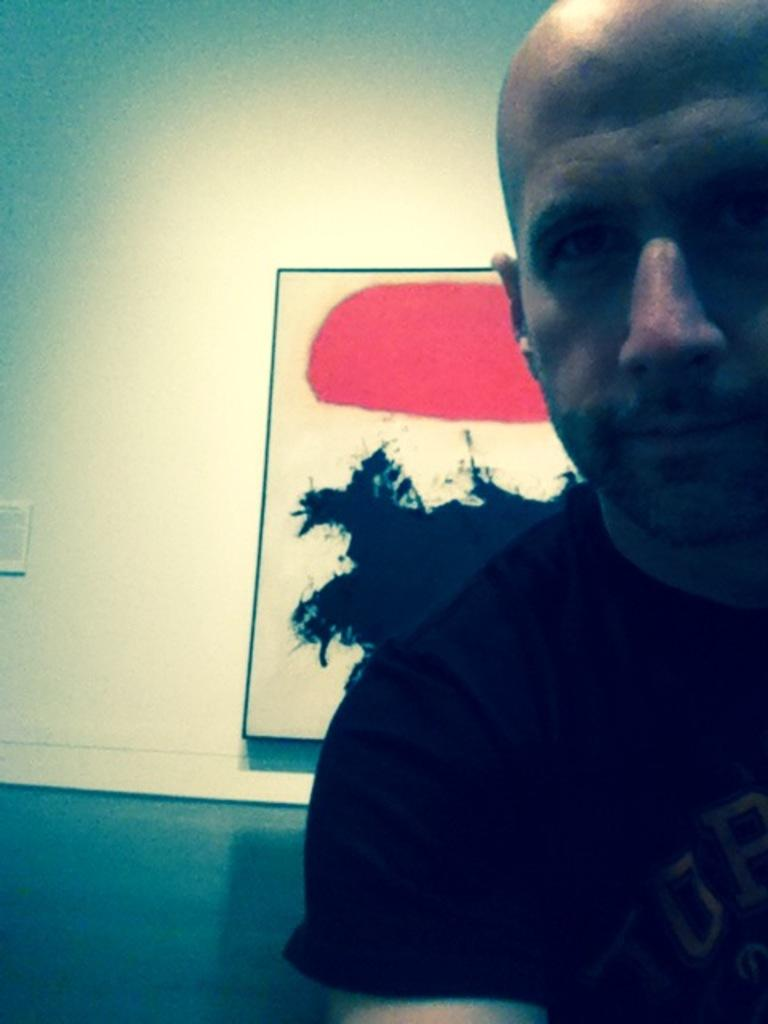Who is present in the image? There is a person in the image. What is the person wearing? The person is wearing a black shirt. What can be seen behind the person in the image? There is a wall visible in the image. What is attached to the wall? There is a photo frame attached to the wall. What type of clover is growing on the person's shirt in the image? There is no clover visible on the person's shirt in the image. 